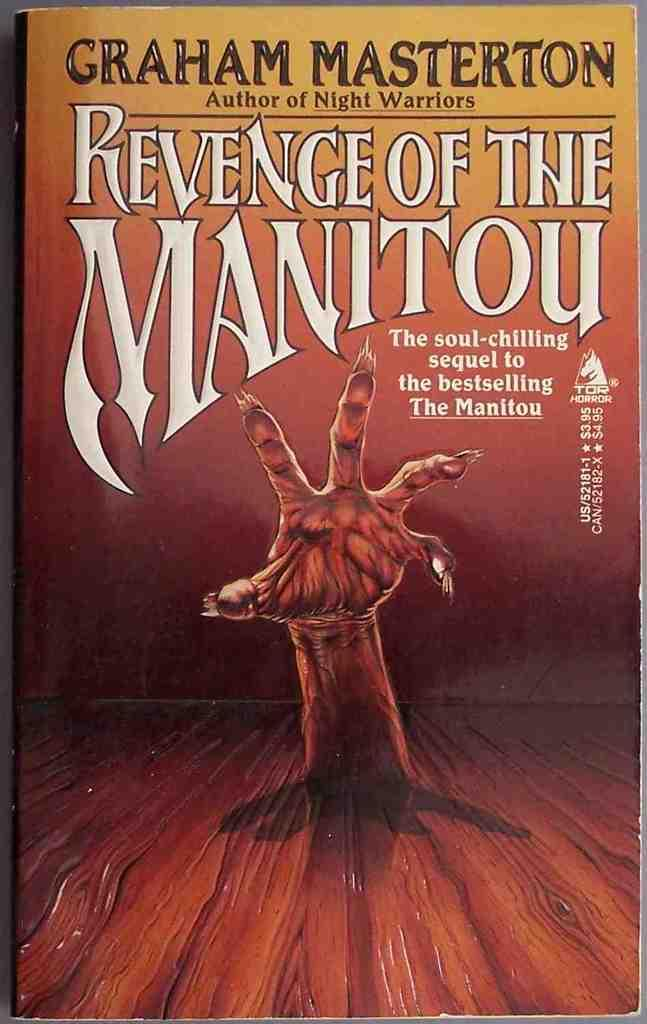What object is present in the image? There is a book in the image. What can be seen on the book? There is a hand on the book, and the title "Revenge of the Manitou" is written on it. What type of brain surgery is being performed on the grandmother in the image? There is no brain surgery or grandmother present in the image; it only features a book with a hand on it. 